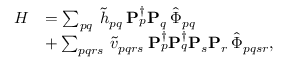<formula> <loc_0><loc_0><loc_500><loc_500>\begin{array} { r l } { H } & { = \sum _ { p q } \, \tilde { h } _ { p q } \, P _ { p } ^ { \dagger } P _ { q } \, \hat { \Phi } _ { p q } } \\ & { + \sum _ { p q r s } \, \tilde { v } _ { p q r s } \, P _ { p } ^ { \dagger } P _ { q } ^ { \dagger } P _ { s } P _ { r } \, \hat { \Phi } _ { p q s r } , } \end{array}</formula> 